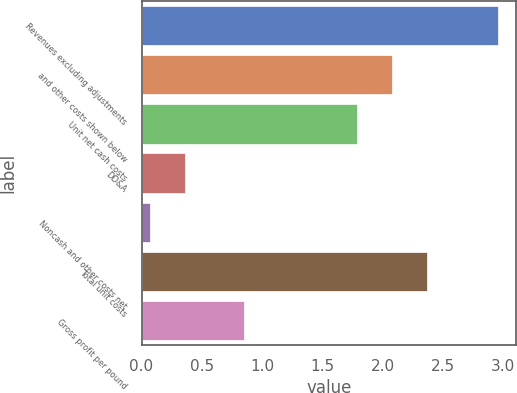Convert chart. <chart><loc_0><loc_0><loc_500><loc_500><bar_chart><fcel>Revenues excluding adjustments<fcel>and other costs shown below<fcel>Unit net cash costs<fcel>DD&A<fcel>Noncash and other costs net<fcel>Total unit costs<fcel>Gross profit per pound<nl><fcel>2.96<fcel>2.08<fcel>1.79<fcel>0.36<fcel>0.07<fcel>2.37<fcel>0.85<nl></chart> 